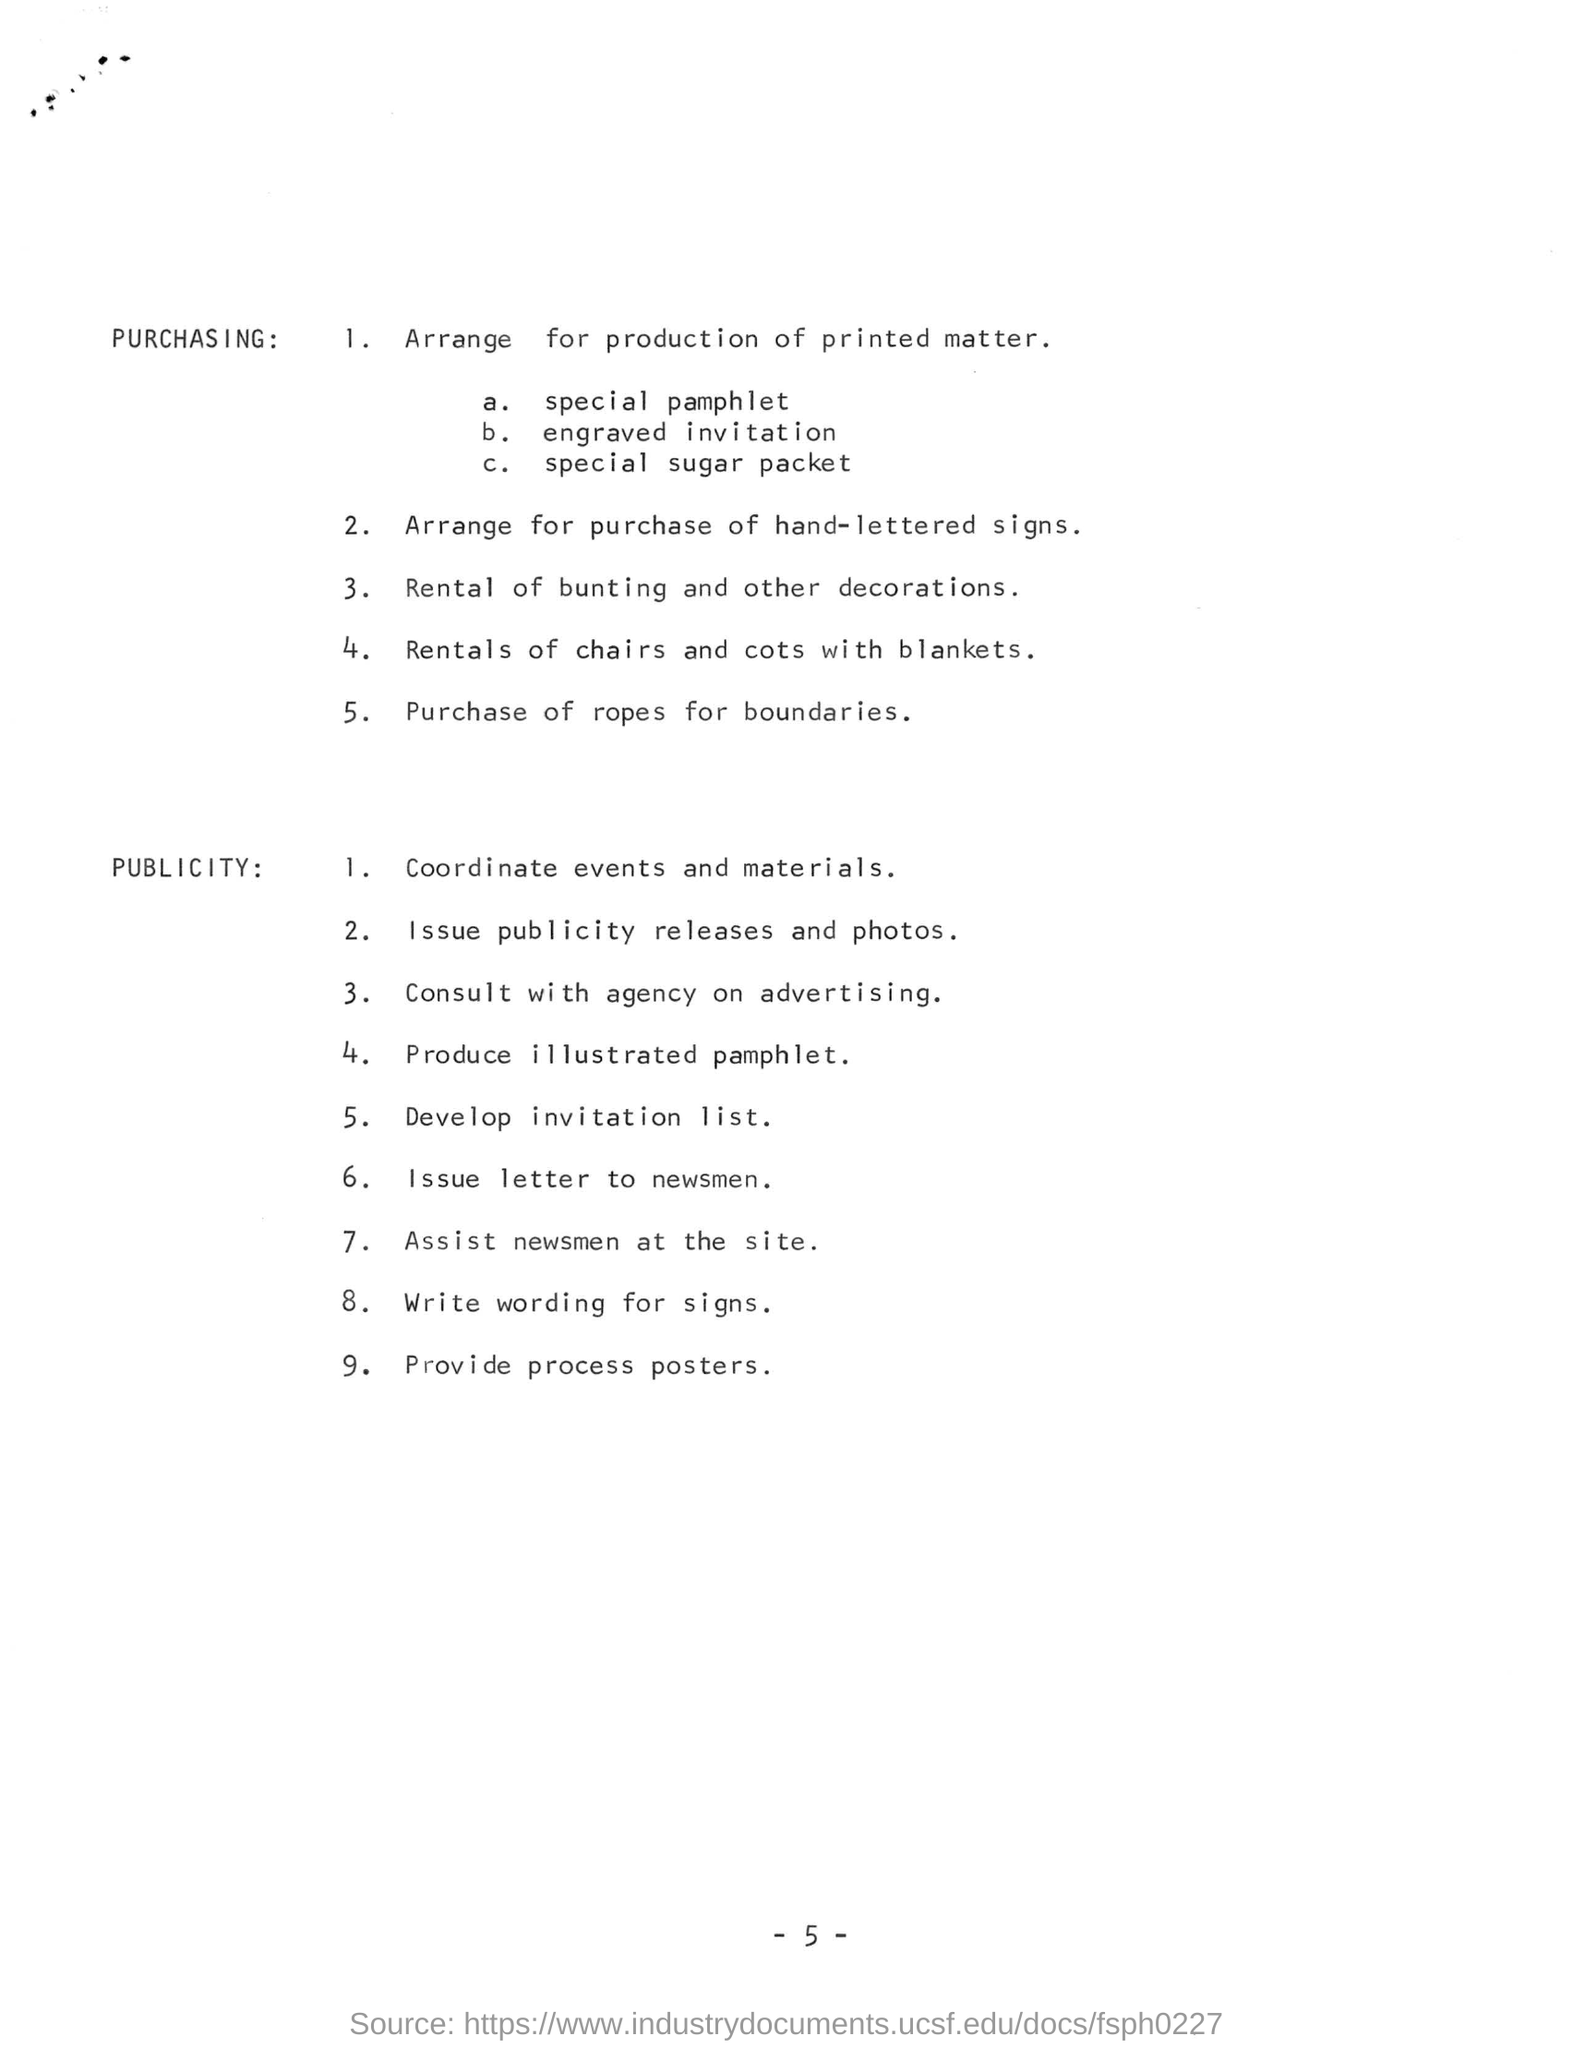How many points are mentioned under publicity?
Provide a succinct answer. 9. Consultation with an agency is for what purpose?
Your answer should be very brief. Advertising. Which posters are to be provided?
Offer a terse response. Process. 